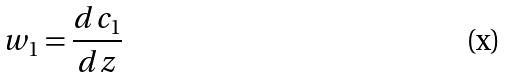<formula> <loc_0><loc_0><loc_500><loc_500>w _ { 1 } = \frac { d c _ { 1 } } { d z }</formula> 